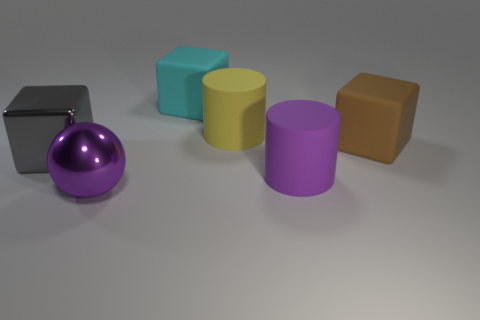Are there fewer cyan matte cubes on the left side of the cyan matte object than purple metallic things that are right of the large yellow matte cylinder?
Your answer should be very brief. No. There is a cube that is on the right side of the large purple metallic sphere and to the left of the purple cylinder; what is its size?
Provide a short and direct response. Large. Are there any large yellow things that are to the right of the big matte cylinder in front of the large block on the left side of the large metallic sphere?
Provide a short and direct response. No. Is there a large green matte sphere?
Your answer should be very brief. No. Is the number of yellow matte things in front of the gray metallic block greater than the number of metallic balls in front of the big ball?
Keep it short and to the point. No. What is the size of the brown thing that is made of the same material as the yellow thing?
Ensure brevity in your answer.  Large. How big is the rubber block behind the large brown block behind the matte thing in front of the large gray metal block?
Ensure brevity in your answer.  Large. What color is the large cube in front of the large brown block?
Your answer should be compact. Gray. Is the number of matte cylinders to the right of the large brown rubber thing greater than the number of purple shiny balls?
Offer a terse response. No. There is a large thing that is right of the large purple rubber cylinder; is it the same shape as the purple matte thing?
Make the answer very short. No. 